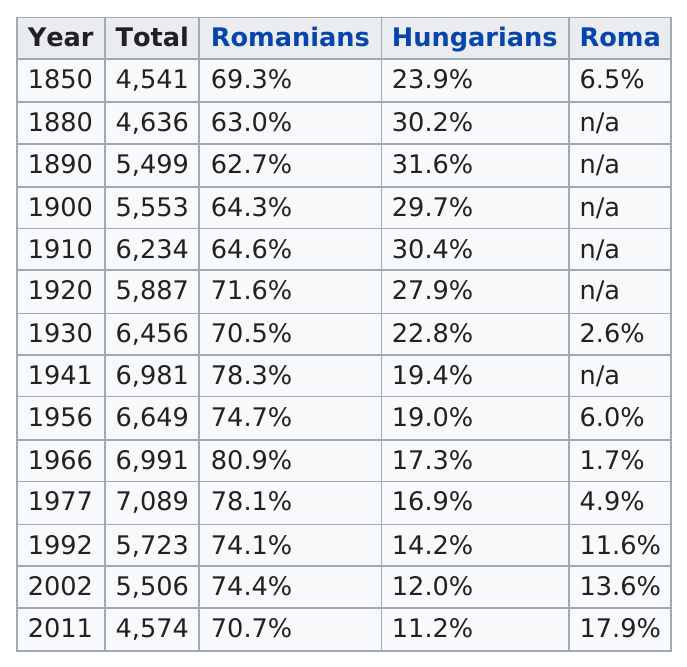Give some essential details in this illustration. In the year 1890, the largest percentage of Hungarians existed. In 1850, the percentage of Hungarians in Hungary was 23.9%. In the year 1941, the total number of Hungarians was 6,981 and represented 19.4% of the population. In the only year when the total population of Romania exceeded 7000, 78.1% of the population was Romanian. In the year 1966, the Romanian population had the highest percentage compared to previous years. 